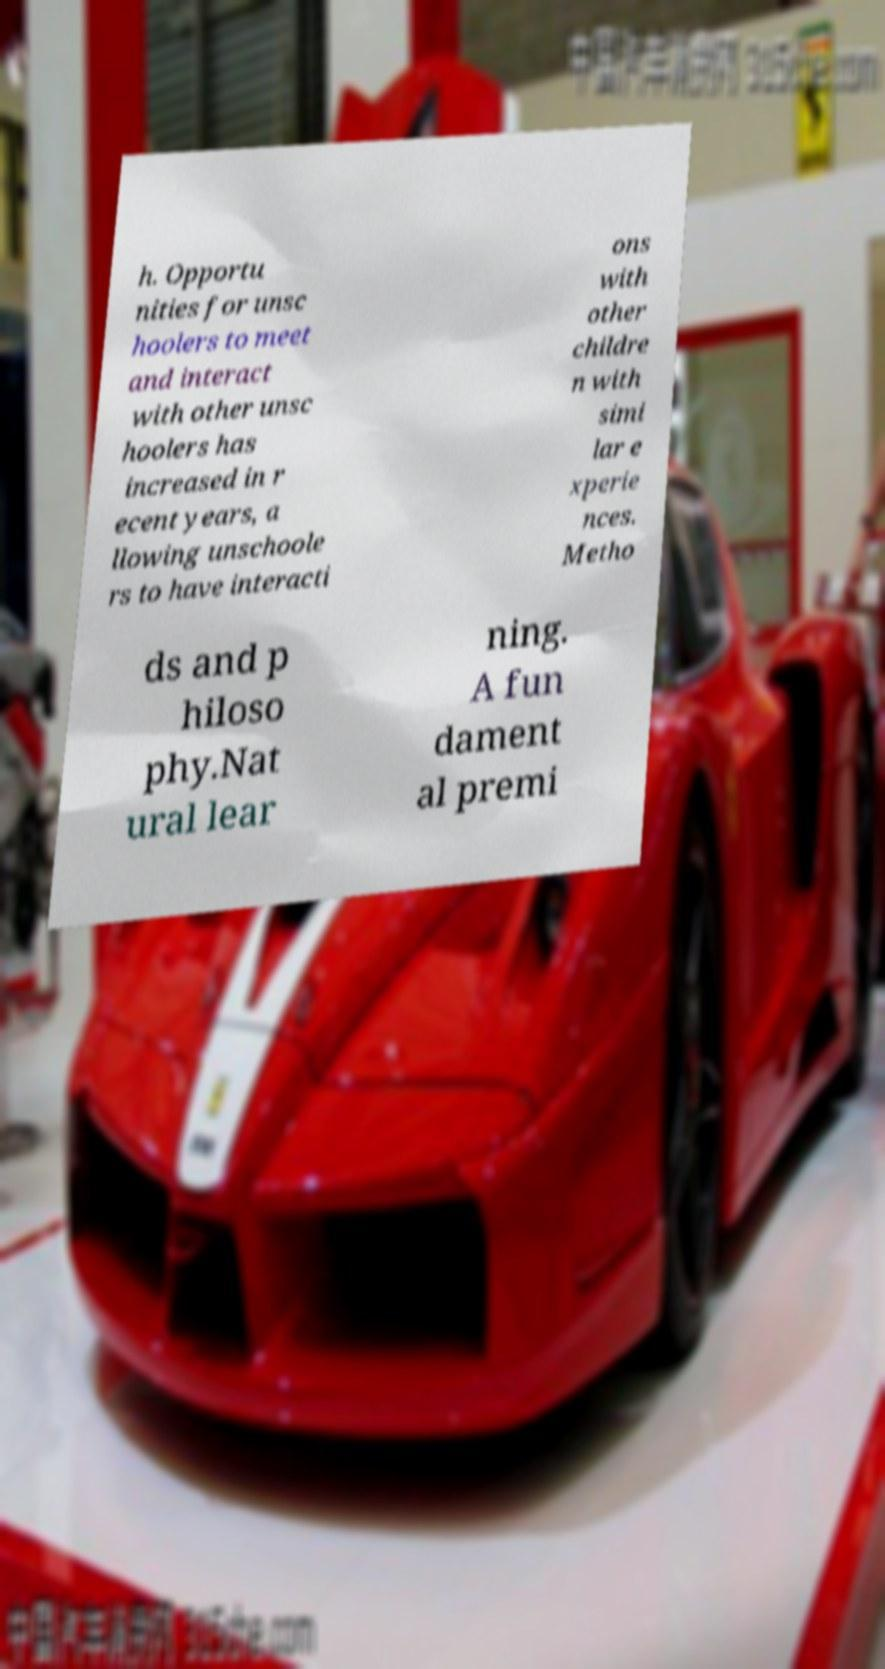Could you extract and type out the text from this image? h. Opportu nities for unsc hoolers to meet and interact with other unsc hoolers has increased in r ecent years, a llowing unschoole rs to have interacti ons with other childre n with simi lar e xperie nces. Metho ds and p hiloso phy.Nat ural lear ning. A fun dament al premi 